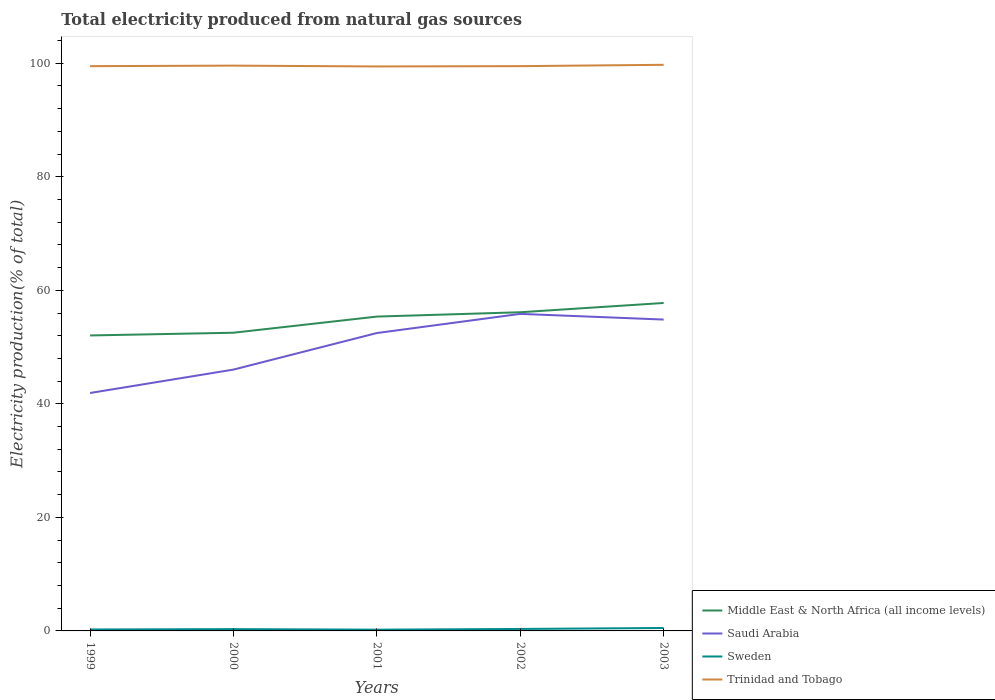How many different coloured lines are there?
Your response must be concise. 4. Across all years, what is the maximum total electricity produced in Sweden?
Ensure brevity in your answer.  0.22. What is the total total electricity produced in Sweden in the graph?
Provide a succinct answer. -0.26. What is the difference between the highest and the second highest total electricity produced in Trinidad and Tobago?
Your answer should be compact. 0.29. What is the difference between the highest and the lowest total electricity produced in Saudi Arabia?
Offer a terse response. 3. How many lines are there?
Offer a very short reply. 4. Does the graph contain any zero values?
Give a very brief answer. No. How many legend labels are there?
Your answer should be compact. 4. How are the legend labels stacked?
Provide a short and direct response. Vertical. What is the title of the graph?
Your answer should be compact. Total electricity produced from natural gas sources. Does "Mali" appear as one of the legend labels in the graph?
Your response must be concise. No. What is the label or title of the X-axis?
Ensure brevity in your answer.  Years. What is the Electricity production(% of total) of Middle East & North Africa (all income levels) in 1999?
Offer a terse response. 52.05. What is the Electricity production(% of total) in Saudi Arabia in 1999?
Provide a succinct answer. 41.91. What is the Electricity production(% of total) of Sweden in 1999?
Give a very brief answer. 0.26. What is the Electricity production(% of total) in Trinidad and Tobago in 1999?
Keep it short and to the point. 99.49. What is the Electricity production(% of total) of Middle East & North Africa (all income levels) in 2000?
Your response must be concise. 52.53. What is the Electricity production(% of total) of Saudi Arabia in 2000?
Give a very brief answer. 46.03. What is the Electricity production(% of total) of Sweden in 2000?
Provide a succinct answer. 0.32. What is the Electricity production(% of total) of Trinidad and Tobago in 2000?
Offer a terse response. 99.58. What is the Electricity production(% of total) of Middle East & North Africa (all income levels) in 2001?
Make the answer very short. 55.37. What is the Electricity production(% of total) in Saudi Arabia in 2001?
Provide a succinct answer. 52.47. What is the Electricity production(% of total) of Sweden in 2001?
Ensure brevity in your answer.  0.22. What is the Electricity production(% of total) in Trinidad and Tobago in 2001?
Give a very brief answer. 99.43. What is the Electricity production(% of total) in Middle East & North Africa (all income levels) in 2002?
Your answer should be compact. 56.13. What is the Electricity production(% of total) in Saudi Arabia in 2002?
Give a very brief answer. 55.85. What is the Electricity production(% of total) in Sweden in 2002?
Provide a succinct answer. 0.35. What is the Electricity production(% of total) of Trinidad and Tobago in 2002?
Offer a terse response. 99.49. What is the Electricity production(% of total) of Middle East & North Africa (all income levels) in 2003?
Give a very brief answer. 57.77. What is the Electricity production(% of total) of Saudi Arabia in 2003?
Your response must be concise. 54.85. What is the Electricity production(% of total) in Sweden in 2003?
Keep it short and to the point. 0.52. What is the Electricity production(% of total) of Trinidad and Tobago in 2003?
Provide a succinct answer. 99.72. Across all years, what is the maximum Electricity production(% of total) in Middle East & North Africa (all income levels)?
Your answer should be very brief. 57.77. Across all years, what is the maximum Electricity production(% of total) of Saudi Arabia?
Keep it short and to the point. 55.85. Across all years, what is the maximum Electricity production(% of total) of Sweden?
Offer a terse response. 0.52. Across all years, what is the maximum Electricity production(% of total) in Trinidad and Tobago?
Provide a succinct answer. 99.72. Across all years, what is the minimum Electricity production(% of total) of Middle East & North Africa (all income levels)?
Make the answer very short. 52.05. Across all years, what is the minimum Electricity production(% of total) in Saudi Arabia?
Your answer should be very brief. 41.91. Across all years, what is the minimum Electricity production(% of total) in Sweden?
Offer a terse response. 0.22. Across all years, what is the minimum Electricity production(% of total) in Trinidad and Tobago?
Give a very brief answer. 99.43. What is the total Electricity production(% of total) in Middle East & North Africa (all income levels) in the graph?
Make the answer very short. 273.85. What is the total Electricity production(% of total) in Saudi Arabia in the graph?
Your answer should be compact. 251.11. What is the total Electricity production(% of total) in Sweden in the graph?
Keep it short and to the point. 1.66. What is the total Electricity production(% of total) of Trinidad and Tobago in the graph?
Provide a succinct answer. 497.7. What is the difference between the Electricity production(% of total) in Middle East & North Africa (all income levels) in 1999 and that in 2000?
Your response must be concise. -0.48. What is the difference between the Electricity production(% of total) in Saudi Arabia in 1999 and that in 2000?
Provide a succinct answer. -4.12. What is the difference between the Electricity production(% of total) of Sweden in 1999 and that in 2000?
Offer a very short reply. -0.06. What is the difference between the Electricity production(% of total) in Trinidad and Tobago in 1999 and that in 2000?
Your response must be concise. -0.09. What is the difference between the Electricity production(% of total) of Middle East & North Africa (all income levels) in 1999 and that in 2001?
Make the answer very short. -3.32. What is the difference between the Electricity production(% of total) of Saudi Arabia in 1999 and that in 2001?
Your answer should be very brief. -10.56. What is the difference between the Electricity production(% of total) in Sweden in 1999 and that in 2001?
Your response must be concise. 0.03. What is the difference between the Electricity production(% of total) in Trinidad and Tobago in 1999 and that in 2001?
Provide a short and direct response. 0.05. What is the difference between the Electricity production(% of total) of Middle East & North Africa (all income levels) in 1999 and that in 2002?
Your response must be concise. -4.09. What is the difference between the Electricity production(% of total) in Saudi Arabia in 1999 and that in 2002?
Your response must be concise. -13.94. What is the difference between the Electricity production(% of total) in Sweden in 1999 and that in 2002?
Provide a short and direct response. -0.09. What is the difference between the Electricity production(% of total) of Trinidad and Tobago in 1999 and that in 2002?
Your answer should be very brief. -0. What is the difference between the Electricity production(% of total) of Middle East & North Africa (all income levels) in 1999 and that in 2003?
Give a very brief answer. -5.72. What is the difference between the Electricity production(% of total) in Saudi Arabia in 1999 and that in 2003?
Your answer should be very brief. -12.94. What is the difference between the Electricity production(% of total) in Sweden in 1999 and that in 2003?
Ensure brevity in your answer.  -0.26. What is the difference between the Electricity production(% of total) of Trinidad and Tobago in 1999 and that in 2003?
Provide a succinct answer. -0.23. What is the difference between the Electricity production(% of total) in Middle East & North Africa (all income levels) in 2000 and that in 2001?
Ensure brevity in your answer.  -2.84. What is the difference between the Electricity production(% of total) of Saudi Arabia in 2000 and that in 2001?
Ensure brevity in your answer.  -6.44. What is the difference between the Electricity production(% of total) of Sweden in 2000 and that in 2001?
Offer a terse response. 0.09. What is the difference between the Electricity production(% of total) in Trinidad and Tobago in 2000 and that in 2001?
Make the answer very short. 0.15. What is the difference between the Electricity production(% of total) in Middle East & North Africa (all income levels) in 2000 and that in 2002?
Keep it short and to the point. -3.61. What is the difference between the Electricity production(% of total) of Saudi Arabia in 2000 and that in 2002?
Provide a short and direct response. -9.81. What is the difference between the Electricity production(% of total) of Sweden in 2000 and that in 2002?
Offer a terse response. -0.03. What is the difference between the Electricity production(% of total) of Trinidad and Tobago in 2000 and that in 2002?
Keep it short and to the point. 0.09. What is the difference between the Electricity production(% of total) of Middle East & North Africa (all income levels) in 2000 and that in 2003?
Your response must be concise. -5.24. What is the difference between the Electricity production(% of total) in Saudi Arabia in 2000 and that in 2003?
Ensure brevity in your answer.  -8.81. What is the difference between the Electricity production(% of total) in Sweden in 2000 and that in 2003?
Your answer should be compact. -0.2. What is the difference between the Electricity production(% of total) of Trinidad and Tobago in 2000 and that in 2003?
Ensure brevity in your answer.  -0.14. What is the difference between the Electricity production(% of total) in Middle East & North Africa (all income levels) in 2001 and that in 2002?
Provide a short and direct response. -0.76. What is the difference between the Electricity production(% of total) in Saudi Arabia in 2001 and that in 2002?
Provide a short and direct response. -3.37. What is the difference between the Electricity production(% of total) of Sweden in 2001 and that in 2002?
Offer a terse response. -0.12. What is the difference between the Electricity production(% of total) of Trinidad and Tobago in 2001 and that in 2002?
Provide a short and direct response. -0.05. What is the difference between the Electricity production(% of total) in Middle East & North Africa (all income levels) in 2001 and that in 2003?
Your answer should be compact. -2.4. What is the difference between the Electricity production(% of total) in Saudi Arabia in 2001 and that in 2003?
Offer a terse response. -2.37. What is the difference between the Electricity production(% of total) of Sweden in 2001 and that in 2003?
Your answer should be compact. -0.29. What is the difference between the Electricity production(% of total) in Trinidad and Tobago in 2001 and that in 2003?
Your response must be concise. -0.29. What is the difference between the Electricity production(% of total) in Middle East & North Africa (all income levels) in 2002 and that in 2003?
Your response must be concise. -1.63. What is the difference between the Electricity production(% of total) in Sweden in 2002 and that in 2003?
Your answer should be very brief. -0.17. What is the difference between the Electricity production(% of total) in Trinidad and Tobago in 2002 and that in 2003?
Your answer should be compact. -0.23. What is the difference between the Electricity production(% of total) of Middle East & North Africa (all income levels) in 1999 and the Electricity production(% of total) of Saudi Arabia in 2000?
Your response must be concise. 6.01. What is the difference between the Electricity production(% of total) in Middle East & North Africa (all income levels) in 1999 and the Electricity production(% of total) in Sweden in 2000?
Your answer should be very brief. 51.73. What is the difference between the Electricity production(% of total) in Middle East & North Africa (all income levels) in 1999 and the Electricity production(% of total) in Trinidad and Tobago in 2000?
Give a very brief answer. -47.53. What is the difference between the Electricity production(% of total) of Saudi Arabia in 1999 and the Electricity production(% of total) of Sweden in 2000?
Your answer should be very brief. 41.59. What is the difference between the Electricity production(% of total) of Saudi Arabia in 1999 and the Electricity production(% of total) of Trinidad and Tobago in 2000?
Your answer should be very brief. -57.67. What is the difference between the Electricity production(% of total) of Sweden in 1999 and the Electricity production(% of total) of Trinidad and Tobago in 2000?
Provide a succinct answer. -99.32. What is the difference between the Electricity production(% of total) in Middle East & North Africa (all income levels) in 1999 and the Electricity production(% of total) in Saudi Arabia in 2001?
Provide a succinct answer. -0.42. What is the difference between the Electricity production(% of total) in Middle East & North Africa (all income levels) in 1999 and the Electricity production(% of total) in Sweden in 2001?
Your answer should be very brief. 51.82. What is the difference between the Electricity production(% of total) of Middle East & North Africa (all income levels) in 1999 and the Electricity production(% of total) of Trinidad and Tobago in 2001?
Offer a terse response. -47.38. What is the difference between the Electricity production(% of total) of Saudi Arabia in 1999 and the Electricity production(% of total) of Sweden in 2001?
Make the answer very short. 41.69. What is the difference between the Electricity production(% of total) of Saudi Arabia in 1999 and the Electricity production(% of total) of Trinidad and Tobago in 2001?
Your response must be concise. -57.52. What is the difference between the Electricity production(% of total) of Sweden in 1999 and the Electricity production(% of total) of Trinidad and Tobago in 2001?
Ensure brevity in your answer.  -99.18. What is the difference between the Electricity production(% of total) in Middle East & North Africa (all income levels) in 1999 and the Electricity production(% of total) in Saudi Arabia in 2002?
Keep it short and to the point. -3.8. What is the difference between the Electricity production(% of total) in Middle East & North Africa (all income levels) in 1999 and the Electricity production(% of total) in Sweden in 2002?
Your answer should be compact. 51.7. What is the difference between the Electricity production(% of total) of Middle East & North Africa (all income levels) in 1999 and the Electricity production(% of total) of Trinidad and Tobago in 2002?
Ensure brevity in your answer.  -47.44. What is the difference between the Electricity production(% of total) in Saudi Arabia in 1999 and the Electricity production(% of total) in Sweden in 2002?
Your answer should be compact. 41.56. What is the difference between the Electricity production(% of total) of Saudi Arabia in 1999 and the Electricity production(% of total) of Trinidad and Tobago in 2002?
Ensure brevity in your answer.  -57.57. What is the difference between the Electricity production(% of total) of Sweden in 1999 and the Electricity production(% of total) of Trinidad and Tobago in 2002?
Provide a short and direct response. -99.23. What is the difference between the Electricity production(% of total) of Middle East & North Africa (all income levels) in 1999 and the Electricity production(% of total) of Saudi Arabia in 2003?
Make the answer very short. -2.8. What is the difference between the Electricity production(% of total) of Middle East & North Africa (all income levels) in 1999 and the Electricity production(% of total) of Sweden in 2003?
Make the answer very short. 51.53. What is the difference between the Electricity production(% of total) in Middle East & North Africa (all income levels) in 1999 and the Electricity production(% of total) in Trinidad and Tobago in 2003?
Your answer should be very brief. -47.67. What is the difference between the Electricity production(% of total) of Saudi Arabia in 1999 and the Electricity production(% of total) of Sweden in 2003?
Make the answer very short. 41.39. What is the difference between the Electricity production(% of total) in Saudi Arabia in 1999 and the Electricity production(% of total) in Trinidad and Tobago in 2003?
Keep it short and to the point. -57.81. What is the difference between the Electricity production(% of total) of Sweden in 1999 and the Electricity production(% of total) of Trinidad and Tobago in 2003?
Make the answer very short. -99.46. What is the difference between the Electricity production(% of total) of Middle East & North Africa (all income levels) in 2000 and the Electricity production(% of total) of Saudi Arabia in 2001?
Give a very brief answer. 0.05. What is the difference between the Electricity production(% of total) of Middle East & North Africa (all income levels) in 2000 and the Electricity production(% of total) of Sweden in 2001?
Give a very brief answer. 52.3. What is the difference between the Electricity production(% of total) in Middle East & North Africa (all income levels) in 2000 and the Electricity production(% of total) in Trinidad and Tobago in 2001?
Offer a very short reply. -46.91. What is the difference between the Electricity production(% of total) in Saudi Arabia in 2000 and the Electricity production(% of total) in Sweden in 2001?
Provide a succinct answer. 45.81. What is the difference between the Electricity production(% of total) of Saudi Arabia in 2000 and the Electricity production(% of total) of Trinidad and Tobago in 2001?
Your response must be concise. -53.4. What is the difference between the Electricity production(% of total) of Sweden in 2000 and the Electricity production(% of total) of Trinidad and Tobago in 2001?
Your response must be concise. -99.11. What is the difference between the Electricity production(% of total) in Middle East & North Africa (all income levels) in 2000 and the Electricity production(% of total) in Saudi Arabia in 2002?
Keep it short and to the point. -3.32. What is the difference between the Electricity production(% of total) in Middle East & North Africa (all income levels) in 2000 and the Electricity production(% of total) in Sweden in 2002?
Provide a succinct answer. 52.18. What is the difference between the Electricity production(% of total) of Middle East & North Africa (all income levels) in 2000 and the Electricity production(% of total) of Trinidad and Tobago in 2002?
Provide a short and direct response. -46.96. What is the difference between the Electricity production(% of total) in Saudi Arabia in 2000 and the Electricity production(% of total) in Sweden in 2002?
Your response must be concise. 45.69. What is the difference between the Electricity production(% of total) in Saudi Arabia in 2000 and the Electricity production(% of total) in Trinidad and Tobago in 2002?
Give a very brief answer. -53.45. What is the difference between the Electricity production(% of total) in Sweden in 2000 and the Electricity production(% of total) in Trinidad and Tobago in 2002?
Offer a terse response. -99.17. What is the difference between the Electricity production(% of total) of Middle East & North Africa (all income levels) in 2000 and the Electricity production(% of total) of Saudi Arabia in 2003?
Your answer should be very brief. -2.32. What is the difference between the Electricity production(% of total) in Middle East & North Africa (all income levels) in 2000 and the Electricity production(% of total) in Sweden in 2003?
Offer a terse response. 52.01. What is the difference between the Electricity production(% of total) in Middle East & North Africa (all income levels) in 2000 and the Electricity production(% of total) in Trinidad and Tobago in 2003?
Keep it short and to the point. -47.19. What is the difference between the Electricity production(% of total) of Saudi Arabia in 2000 and the Electricity production(% of total) of Sweden in 2003?
Ensure brevity in your answer.  45.52. What is the difference between the Electricity production(% of total) of Saudi Arabia in 2000 and the Electricity production(% of total) of Trinidad and Tobago in 2003?
Your answer should be very brief. -53.69. What is the difference between the Electricity production(% of total) in Sweden in 2000 and the Electricity production(% of total) in Trinidad and Tobago in 2003?
Your answer should be very brief. -99.4. What is the difference between the Electricity production(% of total) of Middle East & North Africa (all income levels) in 2001 and the Electricity production(% of total) of Saudi Arabia in 2002?
Provide a short and direct response. -0.48. What is the difference between the Electricity production(% of total) of Middle East & North Africa (all income levels) in 2001 and the Electricity production(% of total) of Sweden in 2002?
Your answer should be very brief. 55.02. What is the difference between the Electricity production(% of total) of Middle East & North Africa (all income levels) in 2001 and the Electricity production(% of total) of Trinidad and Tobago in 2002?
Provide a short and direct response. -44.11. What is the difference between the Electricity production(% of total) in Saudi Arabia in 2001 and the Electricity production(% of total) in Sweden in 2002?
Provide a succinct answer. 52.13. What is the difference between the Electricity production(% of total) in Saudi Arabia in 2001 and the Electricity production(% of total) in Trinidad and Tobago in 2002?
Your answer should be compact. -47.01. What is the difference between the Electricity production(% of total) in Sweden in 2001 and the Electricity production(% of total) in Trinidad and Tobago in 2002?
Keep it short and to the point. -99.26. What is the difference between the Electricity production(% of total) in Middle East & North Africa (all income levels) in 2001 and the Electricity production(% of total) in Saudi Arabia in 2003?
Ensure brevity in your answer.  0.52. What is the difference between the Electricity production(% of total) of Middle East & North Africa (all income levels) in 2001 and the Electricity production(% of total) of Sweden in 2003?
Offer a terse response. 54.85. What is the difference between the Electricity production(% of total) of Middle East & North Africa (all income levels) in 2001 and the Electricity production(% of total) of Trinidad and Tobago in 2003?
Your response must be concise. -44.35. What is the difference between the Electricity production(% of total) in Saudi Arabia in 2001 and the Electricity production(% of total) in Sweden in 2003?
Your answer should be compact. 51.96. What is the difference between the Electricity production(% of total) of Saudi Arabia in 2001 and the Electricity production(% of total) of Trinidad and Tobago in 2003?
Your answer should be compact. -47.25. What is the difference between the Electricity production(% of total) of Sweden in 2001 and the Electricity production(% of total) of Trinidad and Tobago in 2003?
Offer a terse response. -99.5. What is the difference between the Electricity production(% of total) in Middle East & North Africa (all income levels) in 2002 and the Electricity production(% of total) in Saudi Arabia in 2003?
Give a very brief answer. 1.29. What is the difference between the Electricity production(% of total) of Middle East & North Africa (all income levels) in 2002 and the Electricity production(% of total) of Sweden in 2003?
Your answer should be compact. 55.62. What is the difference between the Electricity production(% of total) of Middle East & North Africa (all income levels) in 2002 and the Electricity production(% of total) of Trinidad and Tobago in 2003?
Your response must be concise. -43.59. What is the difference between the Electricity production(% of total) in Saudi Arabia in 2002 and the Electricity production(% of total) in Sweden in 2003?
Provide a succinct answer. 55.33. What is the difference between the Electricity production(% of total) of Saudi Arabia in 2002 and the Electricity production(% of total) of Trinidad and Tobago in 2003?
Your response must be concise. -43.87. What is the difference between the Electricity production(% of total) of Sweden in 2002 and the Electricity production(% of total) of Trinidad and Tobago in 2003?
Keep it short and to the point. -99.37. What is the average Electricity production(% of total) in Middle East & North Africa (all income levels) per year?
Ensure brevity in your answer.  54.77. What is the average Electricity production(% of total) in Saudi Arabia per year?
Give a very brief answer. 50.22. What is the average Electricity production(% of total) of Sweden per year?
Provide a short and direct response. 0.33. What is the average Electricity production(% of total) in Trinidad and Tobago per year?
Provide a short and direct response. 99.54. In the year 1999, what is the difference between the Electricity production(% of total) in Middle East & North Africa (all income levels) and Electricity production(% of total) in Saudi Arabia?
Ensure brevity in your answer.  10.14. In the year 1999, what is the difference between the Electricity production(% of total) in Middle East & North Africa (all income levels) and Electricity production(% of total) in Sweden?
Keep it short and to the point. 51.79. In the year 1999, what is the difference between the Electricity production(% of total) of Middle East & North Africa (all income levels) and Electricity production(% of total) of Trinidad and Tobago?
Keep it short and to the point. -47.44. In the year 1999, what is the difference between the Electricity production(% of total) of Saudi Arabia and Electricity production(% of total) of Sweden?
Offer a terse response. 41.65. In the year 1999, what is the difference between the Electricity production(% of total) in Saudi Arabia and Electricity production(% of total) in Trinidad and Tobago?
Ensure brevity in your answer.  -57.57. In the year 1999, what is the difference between the Electricity production(% of total) of Sweden and Electricity production(% of total) of Trinidad and Tobago?
Ensure brevity in your answer.  -99.23. In the year 2000, what is the difference between the Electricity production(% of total) of Middle East & North Africa (all income levels) and Electricity production(% of total) of Saudi Arabia?
Your response must be concise. 6.49. In the year 2000, what is the difference between the Electricity production(% of total) in Middle East & North Africa (all income levels) and Electricity production(% of total) in Sweden?
Offer a very short reply. 52.21. In the year 2000, what is the difference between the Electricity production(% of total) in Middle East & North Africa (all income levels) and Electricity production(% of total) in Trinidad and Tobago?
Ensure brevity in your answer.  -47.05. In the year 2000, what is the difference between the Electricity production(% of total) of Saudi Arabia and Electricity production(% of total) of Sweden?
Provide a short and direct response. 45.72. In the year 2000, what is the difference between the Electricity production(% of total) of Saudi Arabia and Electricity production(% of total) of Trinidad and Tobago?
Your response must be concise. -53.54. In the year 2000, what is the difference between the Electricity production(% of total) in Sweden and Electricity production(% of total) in Trinidad and Tobago?
Your response must be concise. -99.26. In the year 2001, what is the difference between the Electricity production(% of total) in Middle East & North Africa (all income levels) and Electricity production(% of total) in Saudi Arabia?
Your response must be concise. 2.9. In the year 2001, what is the difference between the Electricity production(% of total) in Middle East & North Africa (all income levels) and Electricity production(% of total) in Sweden?
Provide a short and direct response. 55.15. In the year 2001, what is the difference between the Electricity production(% of total) in Middle East & North Africa (all income levels) and Electricity production(% of total) in Trinidad and Tobago?
Keep it short and to the point. -44.06. In the year 2001, what is the difference between the Electricity production(% of total) in Saudi Arabia and Electricity production(% of total) in Sweden?
Provide a short and direct response. 52.25. In the year 2001, what is the difference between the Electricity production(% of total) of Saudi Arabia and Electricity production(% of total) of Trinidad and Tobago?
Keep it short and to the point. -46.96. In the year 2001, what is the difference between the Electricity production(% of total) in Sweden and Electricity production(% of total) in Trinidad and Tobago?
Provide a succinct answer. -99.21. In the year 2002, what is the difference between the Electricity production(% of total) in Middle East & North Africa (all income levels) and Electricity production(% of total) in Saudi Arabia?
Your answer should be compact. 0.29. In the year 2002, what is the difference between the Electricity production(% of total) in Middle East & North Africa (all income levels) and Electricity production(% of total) in Sweden?
Ensure brevity in your answer.  55.79. In the year 2002, what is the difference between the Electricity production(% of total) of Middle East & North Africa (all income levels) and Electricity production(% of total) of Trinidad and Tobago?
Your response must be concise. -43.35. In the year 2002, what is the difference between the Electricity production(% of total) of Saudi Arabia and Electricity production(% of total) of Sweden?
Your answer should be compact. 55.5. In the year 2002, what is the difference between the Electricity production(% of total) in Saudi Arabia and Electricity production(% of total) in Trinidad and Tobago?
Offer a terse response. -43.64. In the year 2002, what is the difference between the Electricity production(% of total) of Sweden and Electricity production(% of total) of Trinidad and Tobago?
Make the answer very short. -99.14. In the year 2003, what is the difference between the Electricity production(% of total) of Middle East & North Africa (all income levels) and Electricity production(% of total) of Saudi Arabia?
Give a very brief answer. 2.92. In the year 2003, what is the difference between the Electricity production(% of total) in Middle East & North Africa (all income levels) and Electricity production(% of total) in Sweden?
Offer a terse response. 57.25. In the year 2003, what is the difference between the Electricity production(% of total) in Middle East & North Africa (all income levels) and Electricity production(% of total) in Trinidad and Tobago?
Offer a very short reply. -41.95. In the year 2003, what is the difference between the Electricity production(% of total) in Saudi Arabia and Electricity production(% of total) in Sweden?
Your answer should be very brief. 54.33. In the year 2003, what is the difference between the Electricity production(% of total) in Saudi Arabia and Electricity production(% of total) in Trinidad and Tobago?
Ensure brevity in your answer.  -44.87. In the year 2003, what is the difference between the Electricity production(% of total) in Sweden and Electricity production(% of total) in Trinidad and Tobago?
Your answer should be compact. -99.2. What is the ratio of the Electricity production(% of total) of Middle East & North Africa (all income levels) in 1999 to that in 2000?
Your response must be concise. 0.99. What is the ratio of the Electricity production(% of total) of Saudi Arabia in 1999 to that in 2000?
Your answer should be very brief. 0.91. What is the ratio of the Electricity production(% of total) in Sweden in 1999 to that in 2000?
Your answer should be very brief. 0.81. What is the ratio of the Electricity production(% of total) in Trinidad and Tobago in 1999 to that in 2000?
Ensure brevity in your answer.  1. What is the ratio of the Electricity production(% of total) in Middle East & North Africa (all income levels) in 1999 to that in 2001?
Ensure brevity in your answer.  0.94. What is the ratio of the Electricity production(% of total) of Saudi Arabia in 1999 to that in 2001?
Your answer should be compact. 0.8. What is the ratio of the Electricity production(% of total) of Sweden in 1999 to that in 2001?
Offer a terse response. 1.15. What is the ratio of the Electricity production(% of total) in Trinidad and Tobago in 1999 to that in 2001?
Provide a short and direct response. 1. What is the ratio of the Electricity production(% of total) in Middle East & North Africa (all income levels) in 1999 to that in 2002?
Provide a succinct answer. 0.93. What is the ratio of the Electricity production(% of total) in Saudi Arabia in 1999 to that in 2002?
Offer a very short reply. 0.75. What is the ratio of the Electricity production(% of total) of Sweden in 1999 to that in 2002?
Your answer should be compact. 0.74. What is the ratio of the Electricity production(% of total) of Middle East & North Africa (all income levels) in 1999 to that in 2003?
Give a very brief answer. 0.9. What is the ratio of the Electricity production(% of total) of Saudi Arabia in 1999 to that in 2003?
Give a very brief answer. 0.76. What is the ratio of the Electricity production(% of total) in Sweden in 1999 to that in 2003?
Offer a terse response. 0.5. What is the ratio of the Electricity production(% of total) of Trinidad and Tobago in 1999 to that in 2003?
Ensure brevity in your answer.  1. What is the ratio of the Electricity production(% of total) of Middle East & North Africa (all income levels) in 2000 to that in 2001?
Provide a succinct answer. 0.95. What is the ratio of the Electricity production(% of total) in Saudi Arabia in 2000 to that in 2001?
Provide a short and direct response. 0.88. What is the ratio of the Electricity production(% of total) of Sweden in 2000 to that in 2001?
Provide a succinct answer. 1.42. What is the ratio of the Electricity production(% of total) of Trinidad and Tobago in 2000 to that in 2001?
Your answer should be very brief. 1. What is the ratio of the Electricity production(% of total) in Middle East & North Africa (all income levels) in 2000 to that in 2002?
Provide a short and direct response. 0.94. What is the ratio of the Electricity production(% of total) in Saudi Arabia in 2000 to that in 2002?
Provide a short and direct response. 0.82. What is the ratio of the Electricity production(% of total) in Sweden in 2000 to that in 2002?
Offer a very short reply. 0.92. What is the ratio of the Electricity production(% of total) in Trinidad and Tobago in 2000 to that in 2002?
Offer a very short reply. 1. What is the ratio of the Electricity production(% of total) of Middle East & North Africa (all income levels) in 2000 to that in 2003?
Ensure brevity in your answer.  0.91. What is the ratio of the Electricity production(% of total) in Saudi Arabia in 2000 to that in 2003?
Keep it short and to the point. 0.84. What is the ratio of the Electricity production(% of total) of Sweden in 2000 to that in 2003?
Offer a very short reply. 0.62. What is the ratio of the Electricity production(% of total) in Trinidad and Tobago in 2000 to that in 2003?
Provide a succinct answer. 1. What is the ratio of the Electricity production(% of total) of Middle East & North Africa (all income levels) in 2001 to that in 2002?
Make the answer very short. 0.99. What is the ratio of the Electricity production(% of total) of Saudi Arabia in 2001 to that in 2002?
Provide a succinct answer. 0.94. What is the ratio of the Electricity production(% of total) in Sweden in 2001 to that in 2002?
Keep it short and to the point. 0.64. What is the ratio of the Electricity production(% of total) in Middle East & North Africa (all income levels) in 2001 to that in 2003?
Your response must be concise. 0.96. What is the ratio of the Electricity production(% of total) of Saudi Arabia in 2001 to that in 2003?
Ensure brevity in your answer.  0.96. What is the ratio of the Electricity production(% of total) of Sweden in 2001 to that in 2003?
Offer a terse response. 0.43. What is the ratio of the Electricity production(% of total) in Middle East & North Africa (all income levels) in 2002 to that in 2003?
Your answer should be very brief. 0.97. What is the ratio of the Electricity production(% of total) in Saudi Arabia in 2002 to that in 2003?
Offer a very short reply. 1.02. What is the ratio of the Electricity production(% of total) in Sweden in 2002 to that in 2003?
Your answer should be compact. 0.67. What is the difference between the highest and the second highest Electricity production(% of total) of Middle East & North Africa (all income levels)?
Offer a very short reply. 1.63. What is the difference between the highest and the second highest Electricity production(% of total) of Saudi Arabia?
Provide a short and direct response. 1. What is the difference between the highest and the second highest Electricity production(% of total) of Sweden?
Provide a short and direct response. 0.17. What is the difference between the highest and the second highest Electricity production(% of total) in Trinidad and Tobago?
Your answer should be compact. 0.14. What is the difference between the highest and the lowest Electricity production(% of total) in Middle East & North Africa (all income levels)?
Your answer should be compact. 5.72. What is the difference between the highest and the lowest Electricity production(% of total) of Saudi Arabia?
Offer a very short reply. 13.94. What is the difference between the highest and the lowest Electricity production(% of total) of Sweden?
Provide a succinct answer. 0.29. What is the difference between the highest and the lowest Electricity production(% of total) in Trinidad and Tobago?
Make the answer very short. 0.29. 